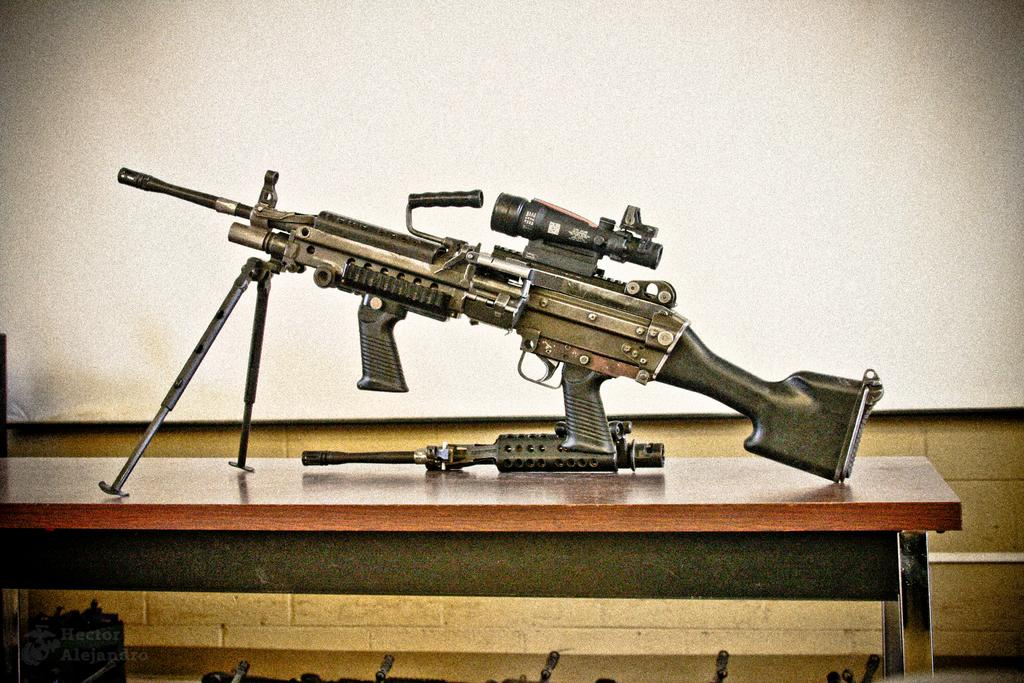What object is the main subject of the image? There is a gun in the image. Where is the gun located? The gun is placed on a table. What color is the background of the image? The background of the image is white. How many girls are holding the heart-shaped needle in the image? There are no girls or heart-shaped needles present in the image. 